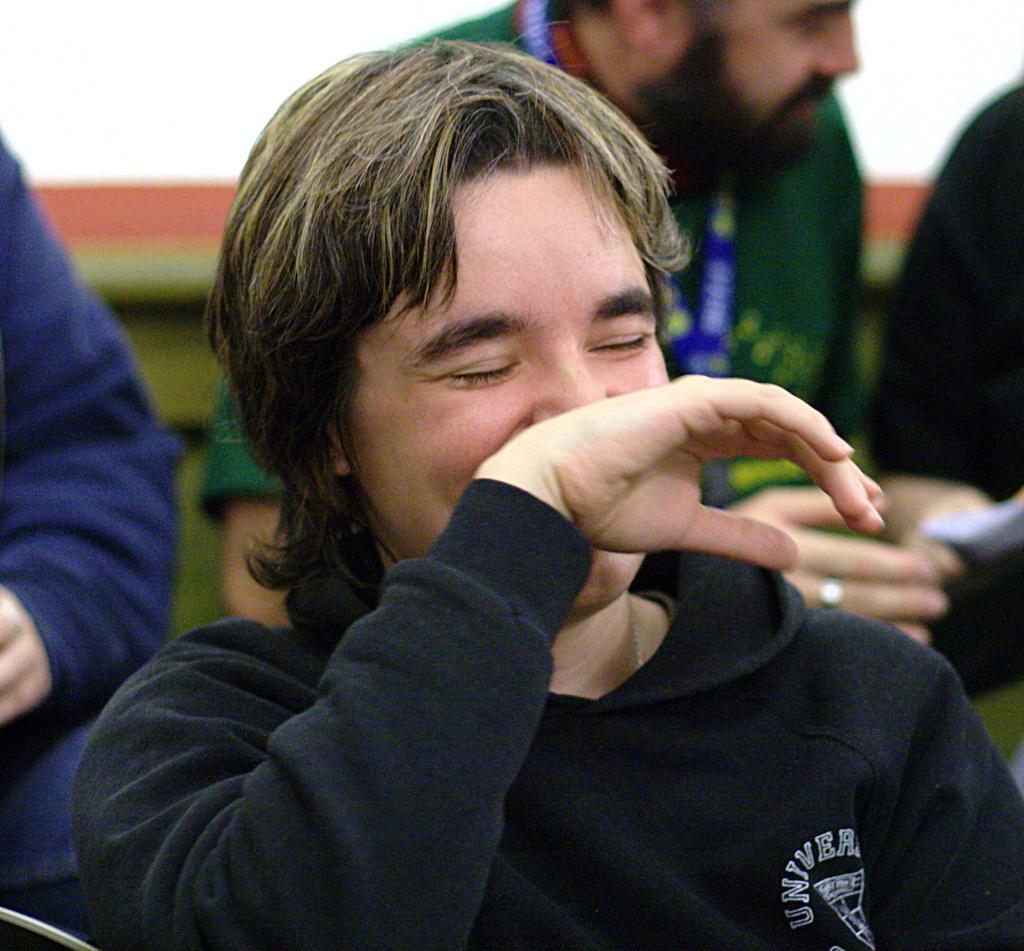Can you describe this image briefly? There is a man smiling and wore black color t shirt. In the background we can see people. 